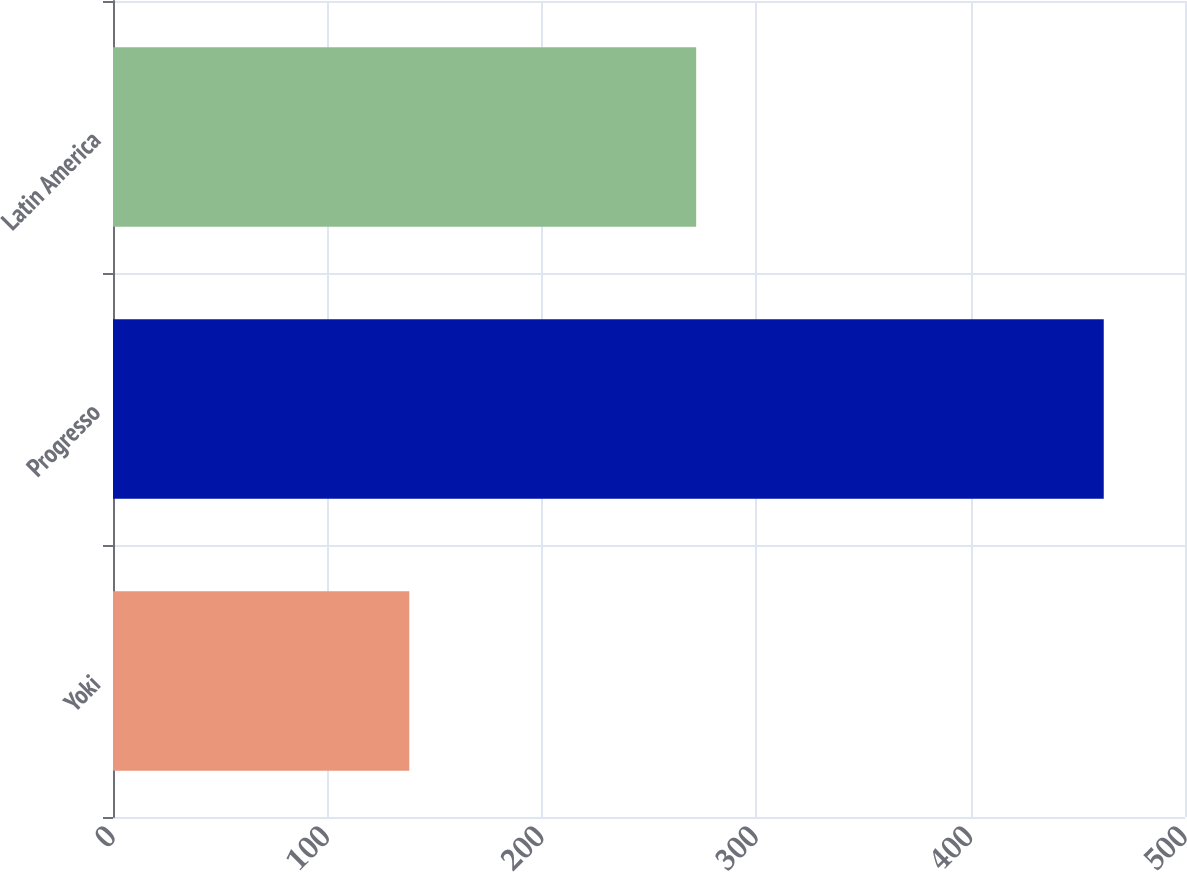Convert chart. <chart><loc_0><loc_0><loc_500><loc_500><bar_chart><fcel>Yoki<fcel>Progresso<fcel>Latin America<nl><fcel>138.2<fcel>462.1<fcel>272<nl></chart> 